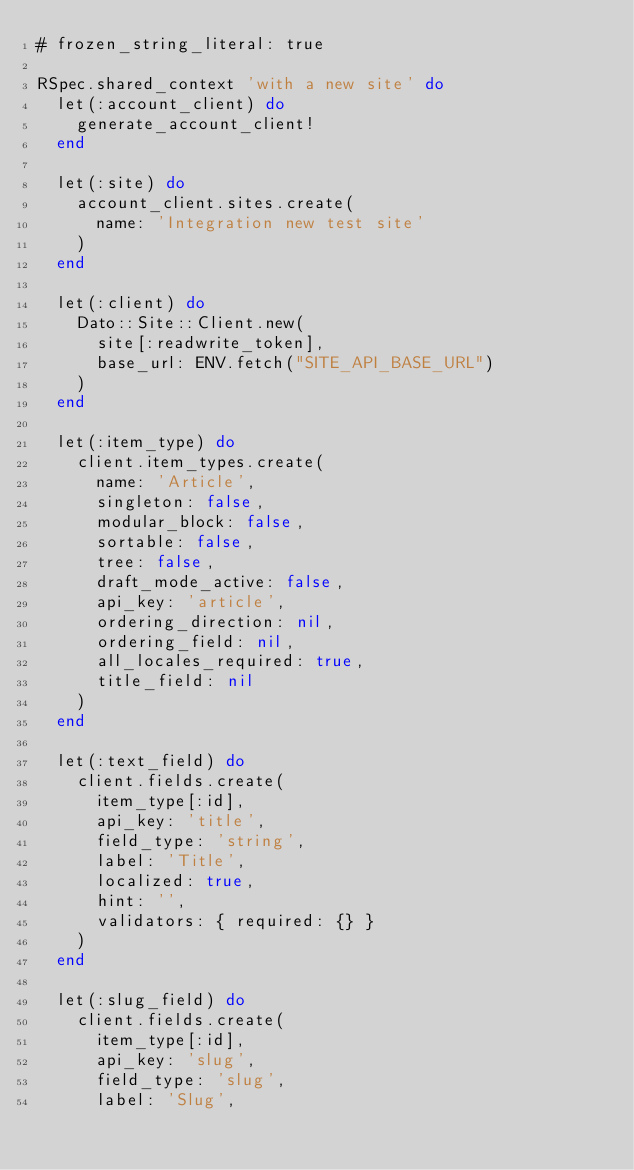Convert code to text. <code><loc_0><loc_0><loc_500><loc_500><_Ruby_># frozen_string_literal: true

RSpec.shared_context 'with a new site' do
  let(:account_client) do
    generate_account_client!
  end

  let(:site) do
    account_client.sites.create(
      name: 'Integration new test site'
    )
  end

  let(:client) do
    Dato::Site::Client.new(
      site[:readwrite_token],
      base_url: ENV.fetch("SITE_API_BASE_URL")
    )
  end

  let(:item_type) do
    client.item_types.create(
      name: 'Article',
      singleton: false,
      modular_block: false,
      sortable: false,
      tree: false,
      draft_mode_active: false,
      api_key: 'article',
      ordering_direction: nil,
      ordering_field: nil,
      all_locales_required: true,
      title_field: nil
    )
  end

  let(:text_field) do
    client.fields.create(
      item_type[:id],
      api_key: 'title',
      field_type: 'string',
      label: 'Title',
      localized: true,
      hint: '',
      validators: { required: {} }
    )
  end

  let(:slug_field) do
    client.fields.create(
      item_type[:id],
      api_key: 'slug',
      field_type: 'slug',
      label: 'Slug',</code> 